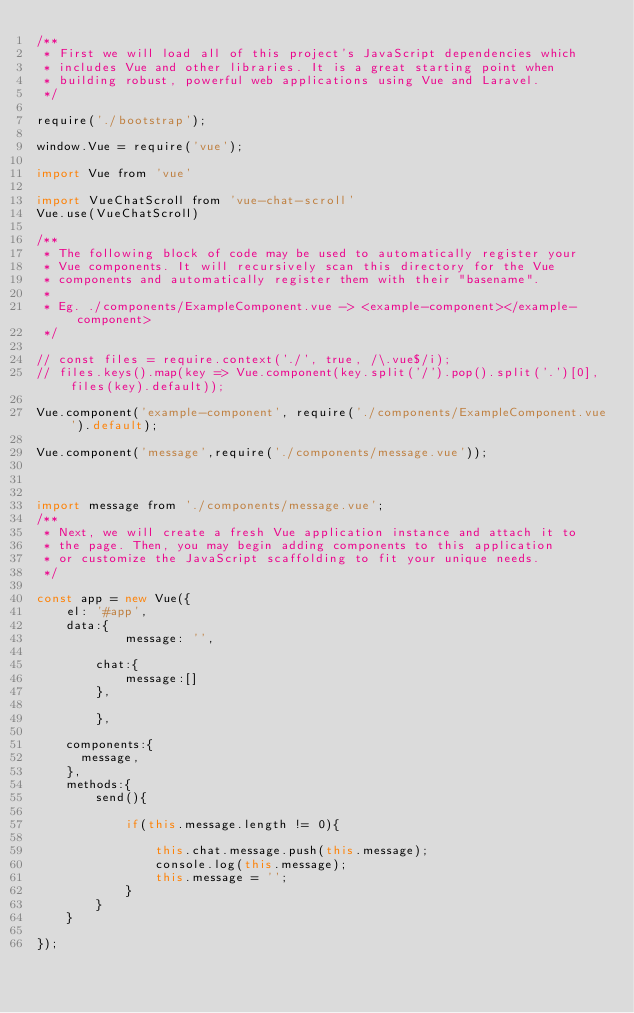Convert code to text. <code><loc_0><loc_0><loc_500><loc_500><_JavaScript_>/**
 * First we will load all of this project's JavaScript dependencies which
 * includes Vue and other libraries. It is a great starting point when
 * building robust, powerful web applications using Vue and Laravel.
 */

require('./bootstrap');

window.Vue = require('vue');

import Vue from 'vue'

import VueChatScroll from 'vue-chat-scroll'
Vue.use(VueChatScroll)

/**
 * The following block of code may be used to automatically register your
 * Vue components. It will recursively scan this directory for the Vue
 * components and automatically register them with their "basename".
 *
 * Eg. ./components/ExampleComponent.vue -> <example-component></example-component>
 */

// const files = require.context('./', true, /\.vue$/i);
// files.keys().map(key => Vue.component(key.split('/').pop().split('.')[0], files(key).default));

Vue.component('example-component', require('./components/ExampleComponent.vue').default);

Vue.component('message',require('./components/message.vue'));



import message from './components/message.vue';
/**
 * Next, we will create a fresh Vue application instance and attach it to
 * the page. Then, you may begin adding components to this application
 * or customize the JavaScript scaffolding to fit your unique needs.
 */

const app = new Vue({
    el: '#app',
    data:{
            message: '',

        chat:{
            message:[]
        },

        },

    components:{
      message,
    },
    methods:{
        send(){

            if(this.message.length != 0){

                this.chat.message.push(this.message);
                console.log(this.message);
                this.message = '';
            }
        }
    }

});
</code> 